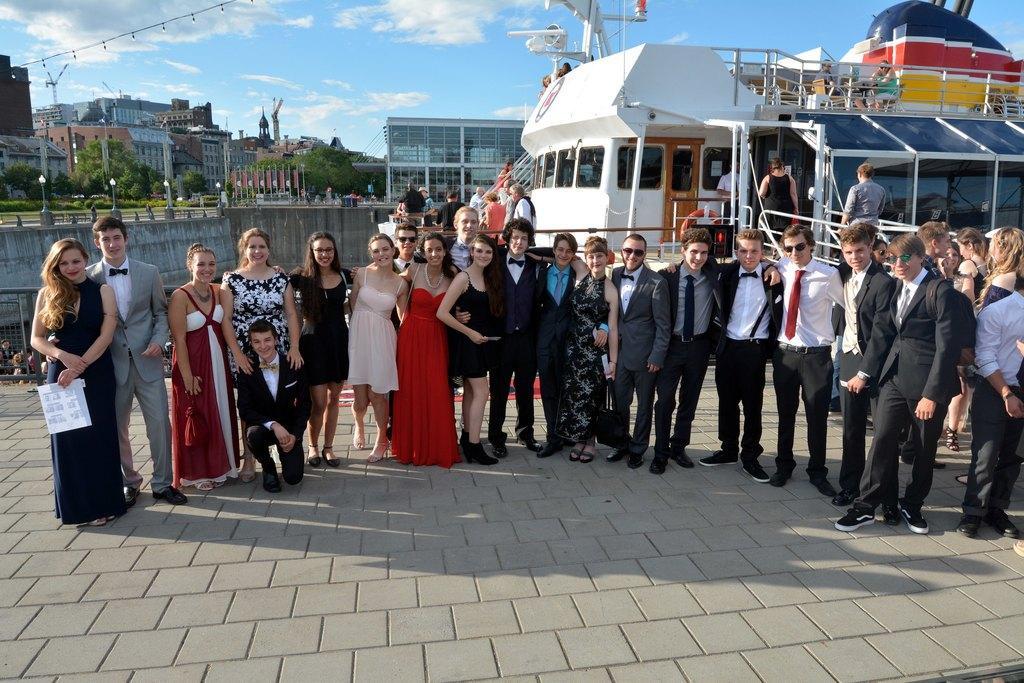Can you describe this image briefly? In this image, we can see people standing and some are wearing coats and ties and we can see some people holding objects in their hands. In the background, there are buildings, trees, lights, poles and we can see a ship. At the top, there are clouds in the sky and at the bottom, there is a road. 